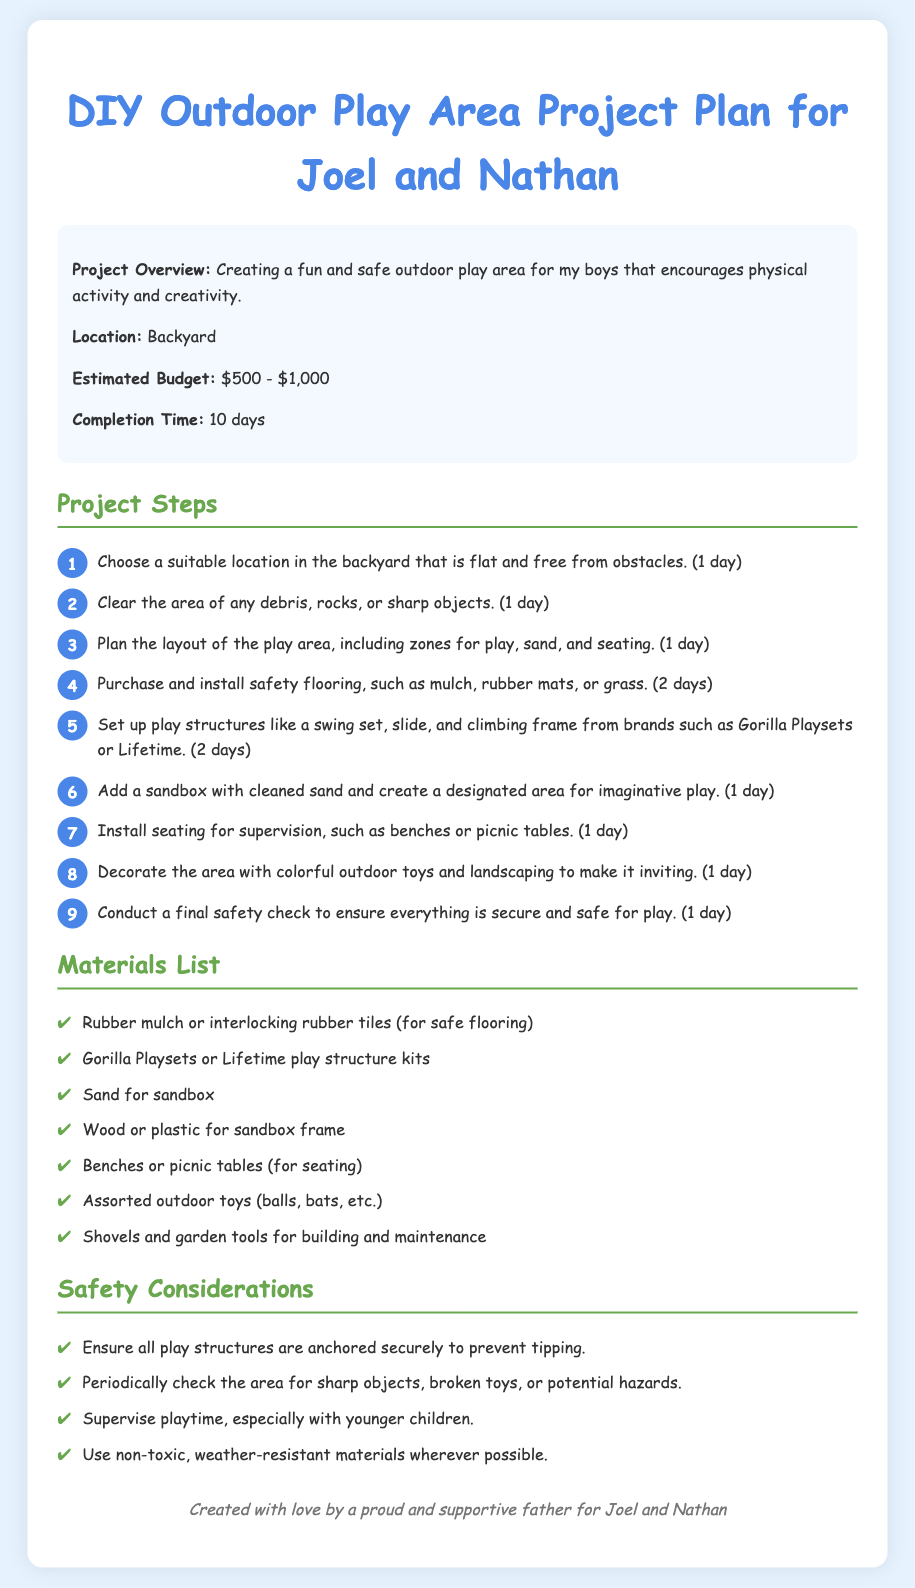What is the main purpose of the project? The project aims to create a fun and safe outdoor play area that encourages physical activity and creativity for the boys.
Answer: Creating a fun and safe outdoor play area Where will the play area be located? The document specifies that the location for the play area is in the backyard.
Answer: Backyard What is the estimated budget range for the project? The budget range indicated for the project is between $500 and $1,000.
Answer: $500 - $1,000 How many days are estimated to complete the project? The document mentions that the estimated completion time for the project is 10 days.
Answer: 10 days What is the first step in the project plan? The first step outlined is to choose a suitable location in the backyard that is flat and free from obstacles.
Answer: Choose a suitable location What type of flooring is suggested for safety? The materials list recommends using rubber mulch or interlocking rubber tiles for safe flooring.
Answer: Rubber mulch or interlocking rubber tiles Name one of the brands mentioned for play structures. The document cites Gorilla Playsets as one of the recommended brands for play structures.
Answer: Gorilla Playsets What is a safety consideration mentioned for the play area? One safety consideration includes ensuring that all play structures are anchored securely to prevent tipping.
Answer: Ensure all play structures are anchored securely What should be done after setting up the play area? A final safety check should be conducted to ensure everything is secure and safe for play.
Answer: Conduct a final safety check 